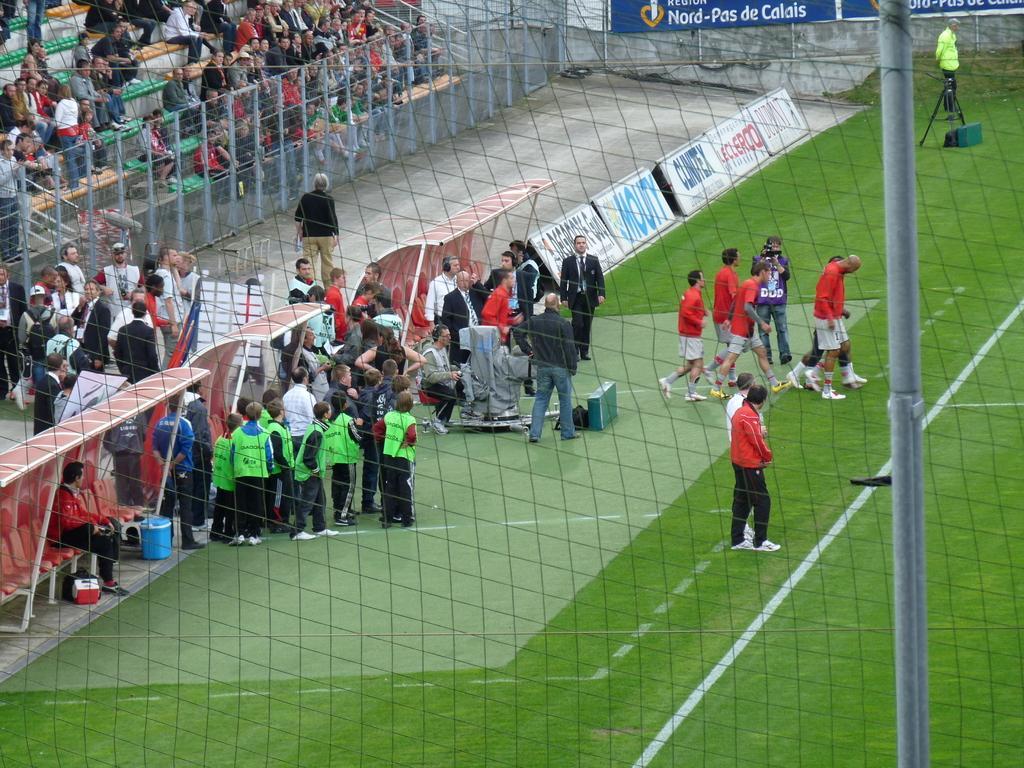In one or two sentences, can you explain what this image depicts? In this picture I can see there are a group of people standing here and they are wearing orange and green shirts and they are few audience sitting here in the chairs and there is a fence here and there are banners and a person standing here wearing a green coat. 